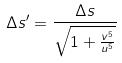Convert formula to latex. <formula><loc_0><loc_0><loc_500><loc_500>\Delta s ^ { \prime } = \frac { \Delta s } { \sqrt { 1 + \frac { v ^ { 5 } } { u ^ { 5 } } } }</formula> 